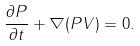Convert formula to latex. <formula><loc_0><loc_0><loc_500><loc_500>\frac { \partial P } { \partial t } + \nabla ( P V ) = 0 .</formula> 